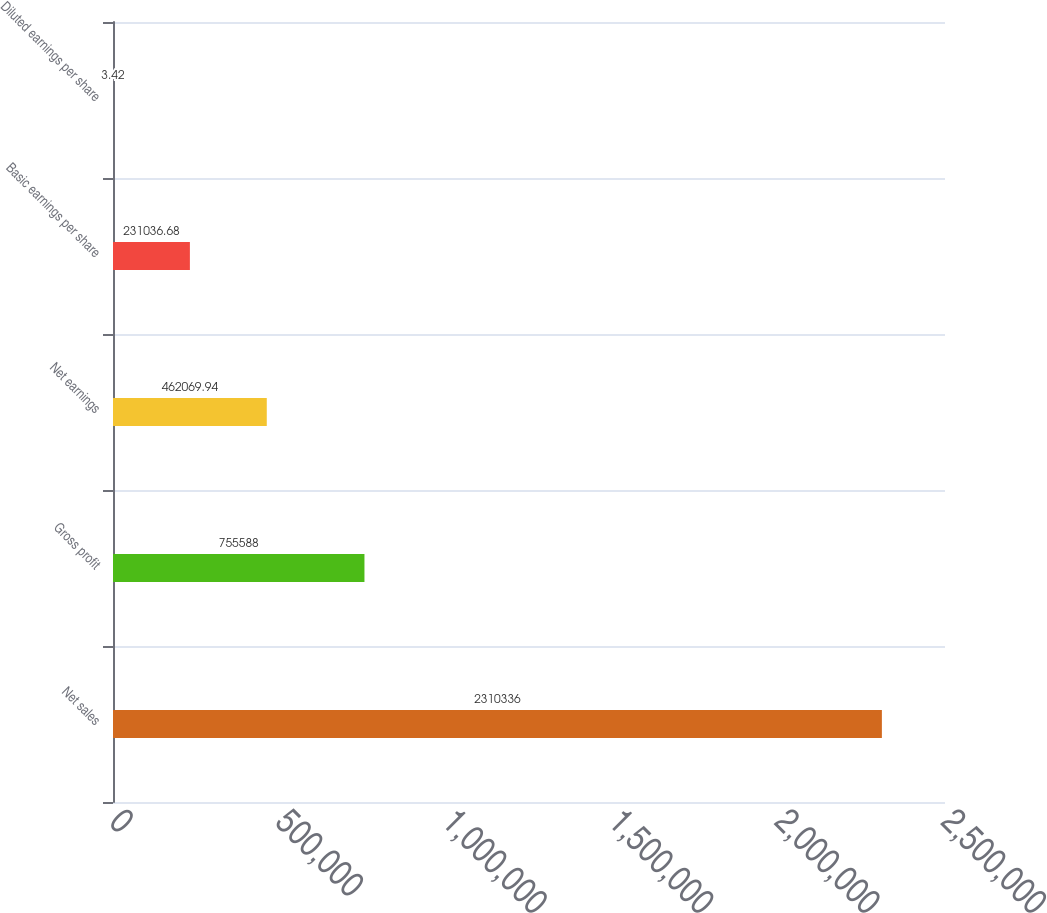<chart> <loc_0><loc_0><loc_500><loc_500><bar_chart><fcel>Net sales<fcel>Gross profit<fcel>Net earnings<fcel>Basic earnings per share<fcel>Diluted earnings per share<nl><fcel>2.31034e+06<fcel>755588<fcel>462070<fcel>231037<fcel>3.42<nl></chart> 